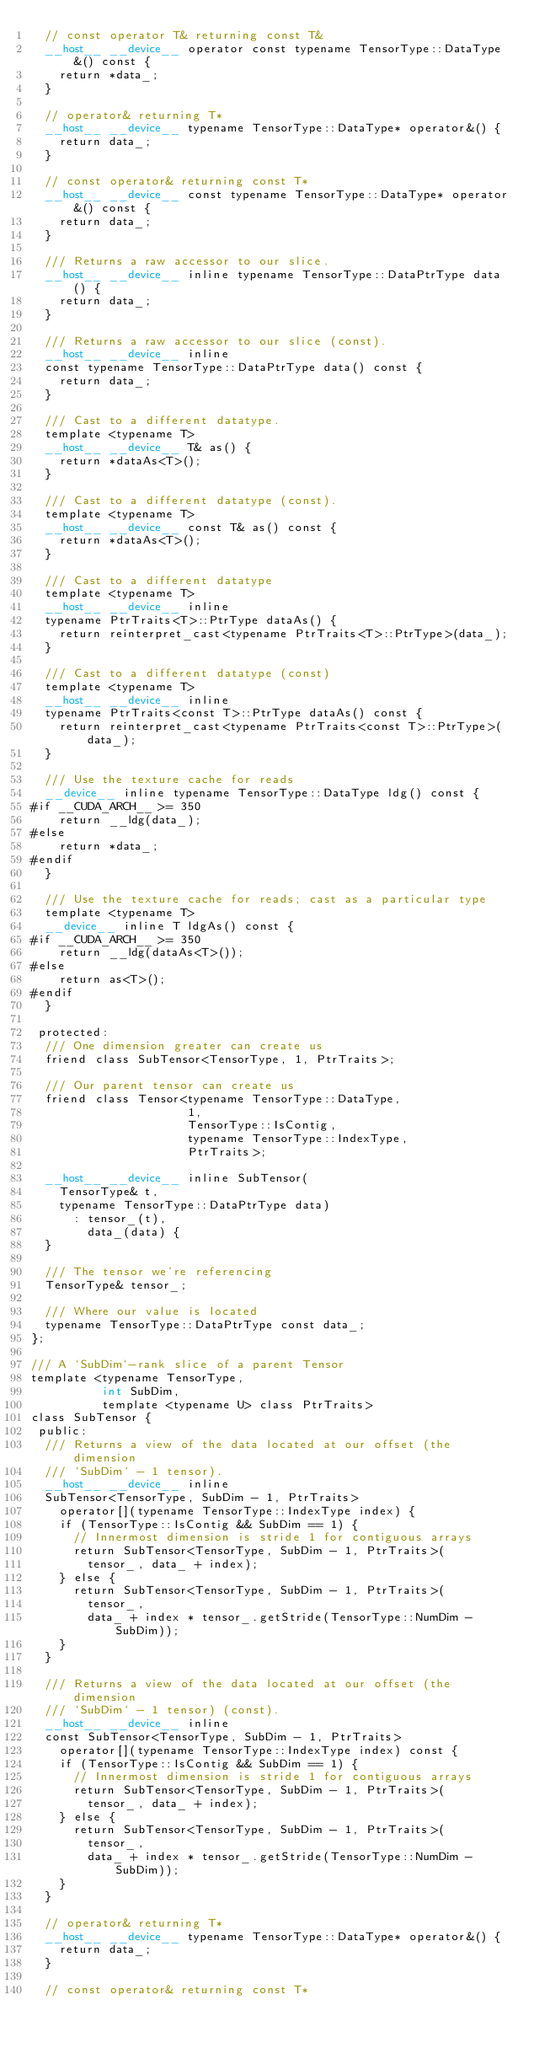Convert code to text. <code><loc_0><loc_0><loc_500><loc_500><_Cuda_>  // const operator T& returning const T&
  __host__ __device__ operator const typename TensorType::DataType&() const {
    return *data_;
  }

  // operator& returning T*
  __host__ __device__ typename TensorType::DataType* operator&() {
    return data_;
  }

  // const operator& returning const T*
  __host__ __device__ const typename TensorType::DataType* operator&() const {
    return data_;
  }

  /// Returns a raw accessor to our slice.
  __host__ __device__ inline typename TensorType::DataPtrType data() {
    return data_;
  }

  /// Returns a raw accessor to our slice (const).
  __host__ __device__ inline
  const typename TensorType::DataPtrType data() const {
    return data_;
  }

  /// Cast to a different datatype.
  template <typename T>
  __host__ __device__ T& as() {
    return *dataAs<T>();
  }

  /// Cast to a different datatype (const).
  template <typename T>
  __host__ __device__ const T& as() const {
    return *dataAs<T>();
  }

  /// Cast to a different datatype
  template <typename T>
  __host__ __device__ inline
  typename PtrTraits<T>::PtrType dataAs() {
    return reinterpret_cast<typename PtrTraits<T>::PtrType>(data_);
  }

  /// Cast to a different datatype (const)
  template <typename T>
  __host__ __device__ inline
  typename PtrTraits<const T>::PtrType dataAs() const {
    return reinterpret_cast<typename PtrTraits<const T>::PtrType>(data_);
  }

  /// Use the texture cache for reads
  __device__ inline typename TensorType::DataType ldg() const {
#if __CUDA_ARCH__ >= 350
    return __ldg(data_);
#else
    return *data_;
#endif
  }

  /// Use the texture cache for reads; cast as a particular type
  template <typename T>
  __device__ inline T ldgAs() const {
#if __CUDA_ARCH__ >= 350
    return __ldg(dataAs<T>());
#else
    return as<T>();
#endif
  }

 protected:
  /// One dimension greater can create us
  friend class SubTensor<TensorType, 1, PtrTraits>;

  /// Our parent tensor can create us
  friend class Tensor<typename TensorType::DataType,
                      1,
                      TensorType::IsContig,
                      typename TensorType::IndexType,
                      PtrTraits>;

  __host__ __device__ inline SubTensor(
    TensorType& t,
    typename TensorType::DataPtrType data)
      : tensor_(t),
        data_(data) {
  }

  /// The tensor we're referencing
  TensorType& tensor_;

  /// Where our value is located
  typename TensorType::DataPtrType const data_;
};

/// A `SubDim`-rank slice of a parent Tensor
template <typename TensorType,
          int SubDim,
          template <typename U> class PtrTraits>
class SubTensor {
 public:
  /// Returns a view of the data located at our offset (the dimension
  /// `SubDim` - 1 tensor).
  __host__ __device__ inline
  SubTensor<TensorType, SubDim - 1, PtrTraits>
    operator[](typename TensorType::IndexType index) {
    if (TensorType::IsContig && SubDim == 1) {
      // Innermost dimension is stride 1 for contiguous arrays
      return SubTensor<TensorType, SubDim - 1, PtrTraits>(
        tensor_, data_ + index);
    } else {
      return SubTensor<TensorType, SubDim - 1, PtrTraits>(
        tensor_,
        data_ + index * tensor_.getStride(TensorType::NumDim - SubDim));
    }
  }

  /// Returns a view of the data located at our offset (the dimension
  /// `SubDim` - 1 tensor) (const).
  __host__ __device__ inline
  const SubTensor<TensorType, SubDim - 1, PtrTraits>
    operator[](typename TensorType::IndexType index) const {
    if (TensorType::IsContig && SubDim == 1) {
      // Innermost dimension is stride 1 for contiguous arrays
      return SubTensor<TensorType, SubDim - 1, PtrTraits>(
        tensor_, data_ + index);
    } else {
      return SubTensor<TensorType, SubDim - 1, PtrTraits>(
        tensor_,
        data_ + index * tensor_.getStride(TensorType::NumDim - SubDim));
    }
  }

  // operator& returning T*
  __host__ __device__ typename TensorType::DataType* operator&() {
    return data_;
  }

  // const operator& returning const T*</code> 